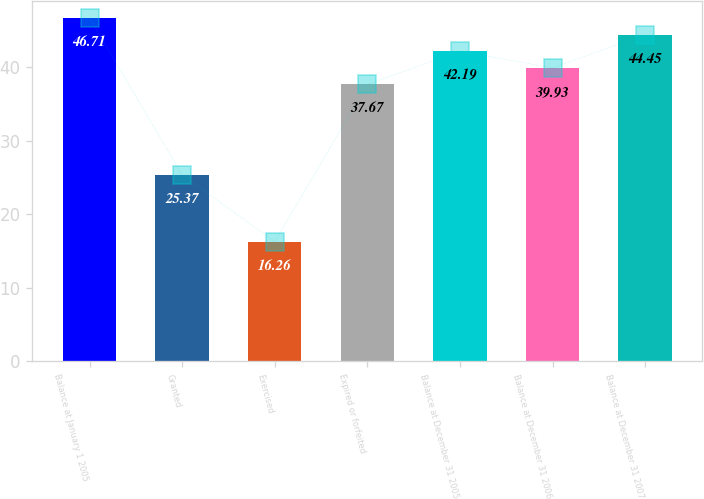Convert chart. <chart><loc_0><loc_0><loc_500><loc_500><bar_chart><fcel>Balance at January 1 2005<fcel>Granted<fcel>Exercised<fcel>Expired or forfeited<fcel>Balance at December 31 2005<fcel>Balance at December 31 2006<fcel>Balance at December 31 2007<nl><fcel>46.71<fcel>25.37<fcel>16.26<fcel>37.67<fcel>42.19<fcel>39.93<fcel>44.45<nl></chart> 